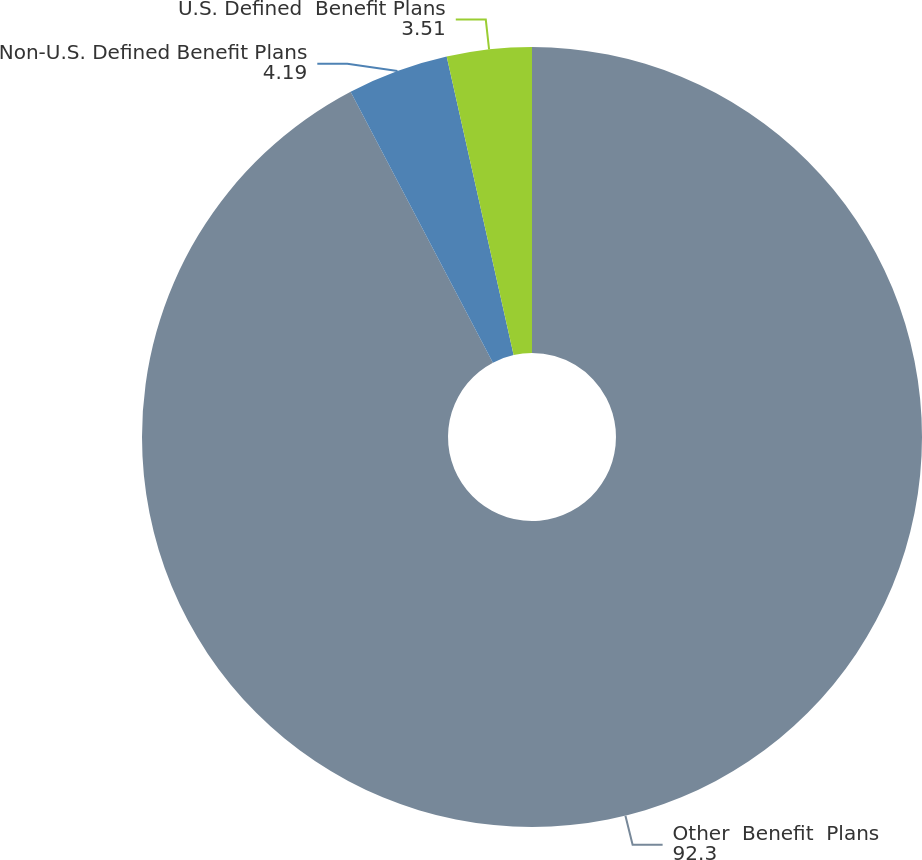Convert chart. <chart><loc_0><loc_0><loc_500><loc_500><pie_chart><fcel>Other  Benefit  Plans<fcel>Non-U.S. Defined Benefit Plans<fcel>U.S. Defined  Benefit Plans<nl><fcel>92.3%<fcel>4.19%<fcel>3.51%<nl></chart> 